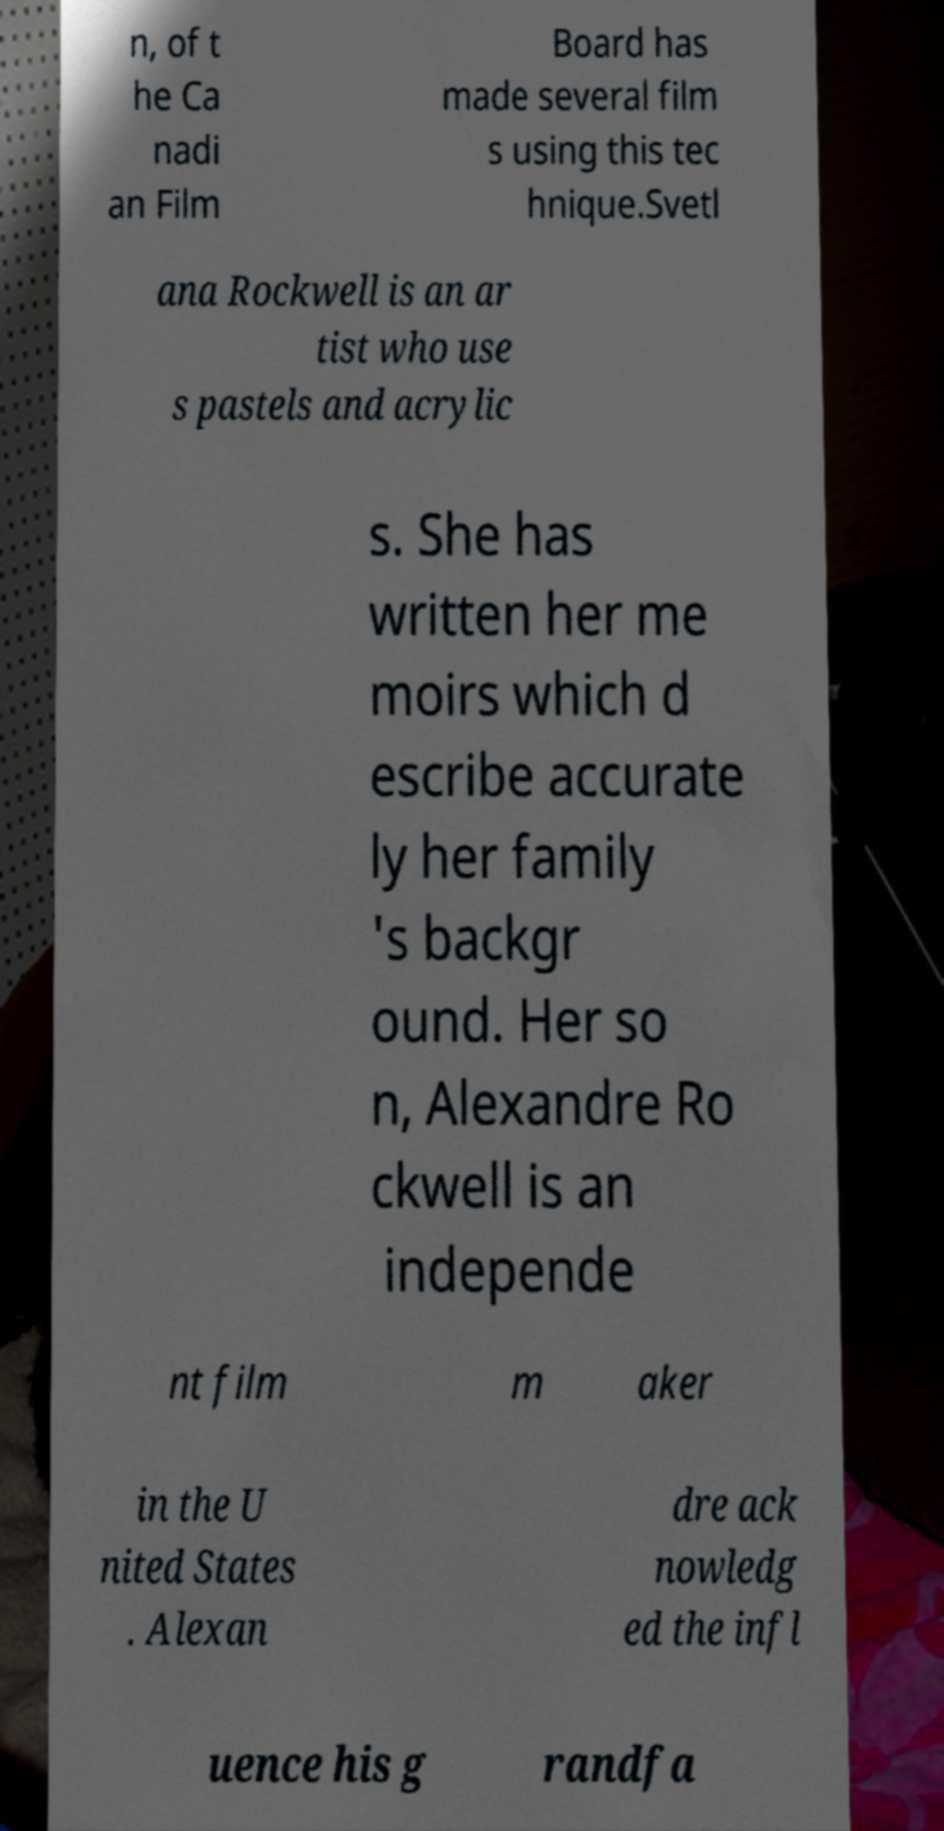Could you extract and type out the text from this image? n, of t he Ca nadi an Film Board has made several film s using this tec hnique.Svetl ana Rockwell is an ar tist who use s pastels and acrylic s. She has written her me moirs which d escribe accurate ly her family 's backgr ound. Her so n, Alexandre Ro ckwell is an independe nt film m aker in the U nited States . Alexan dre ack nowledg ed the infl uence his g randfa 